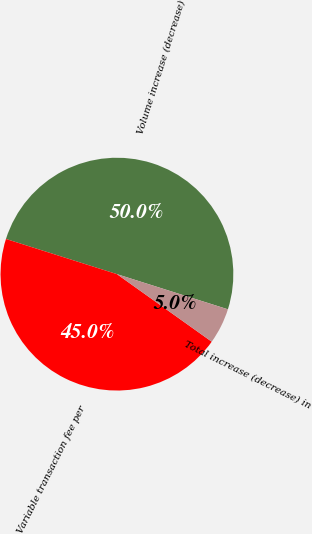Convert chart to OTSL. <chart><loc_0><loc_0><loc_500><loc_500><pie_chart><fcel>Volume increase (decrease)<fcel>Variable transaction fee per<fcel>Total increase (decrease) in<nl><fcel>50.0%<fcel>45.03%<fcel>4.97%<nl></chart> 